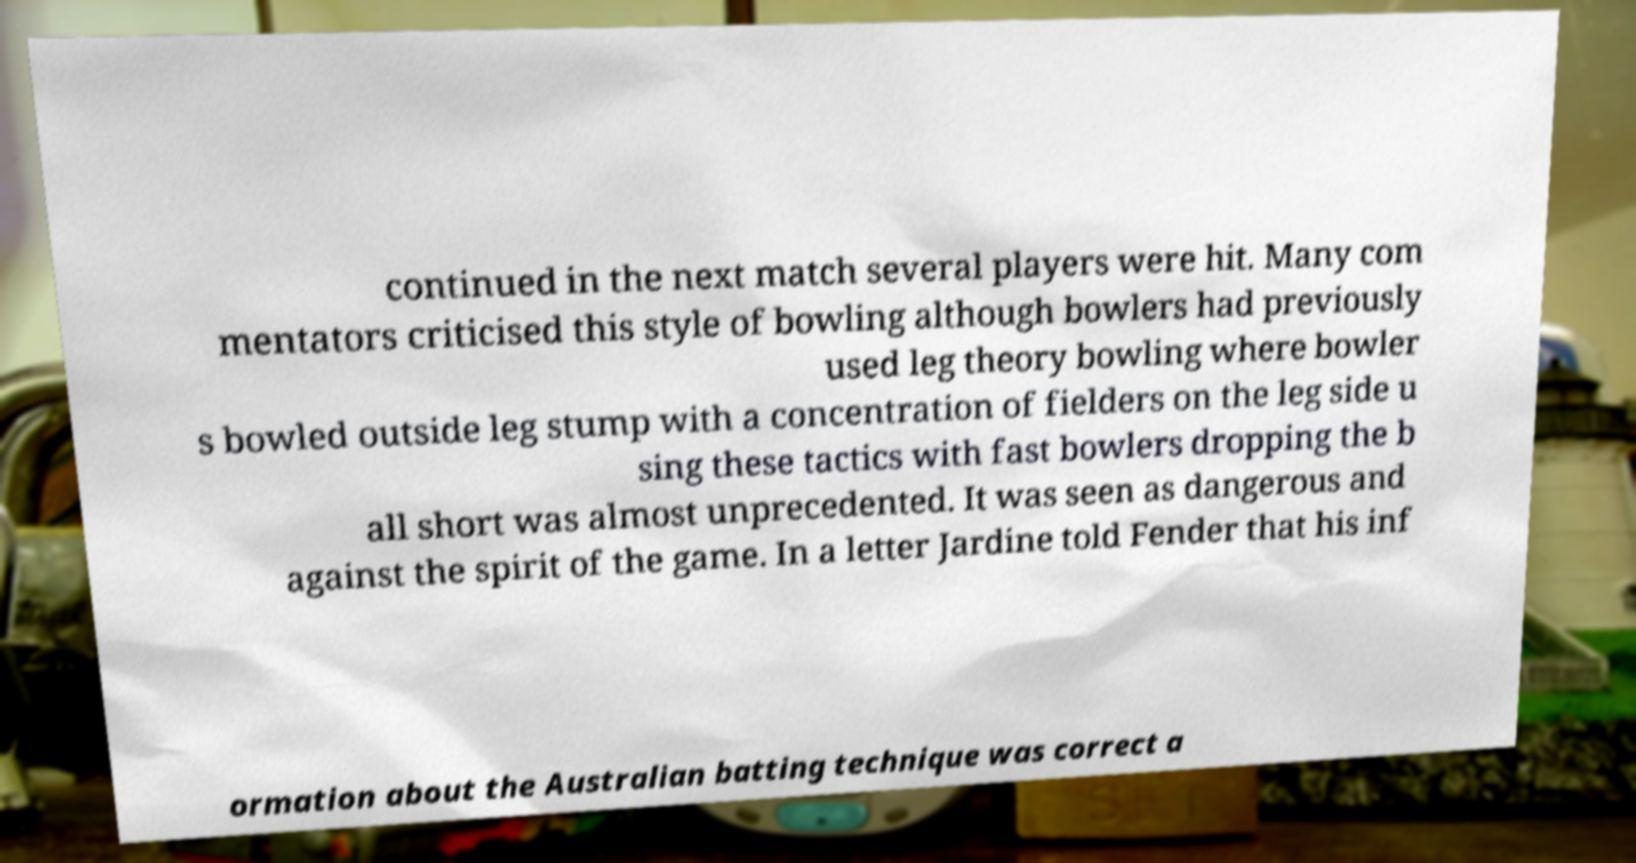What messages or text are displayed in this image? I need them in a readable, typed format. continued in the next match several players were hit. Many com mentators criticised this style of bowling although bowlers had previously used leg theory bowling where bowler s bowled outside leg stump with a concentration of fielders on the leg side u sing these tactics with fast bowlers dropping the b all short was almost unprecedented. It was seen as dangerous and against the spirit of the game. In a letter Jardine told Fender that his inf ormation about the Australian batting technique was correct a 